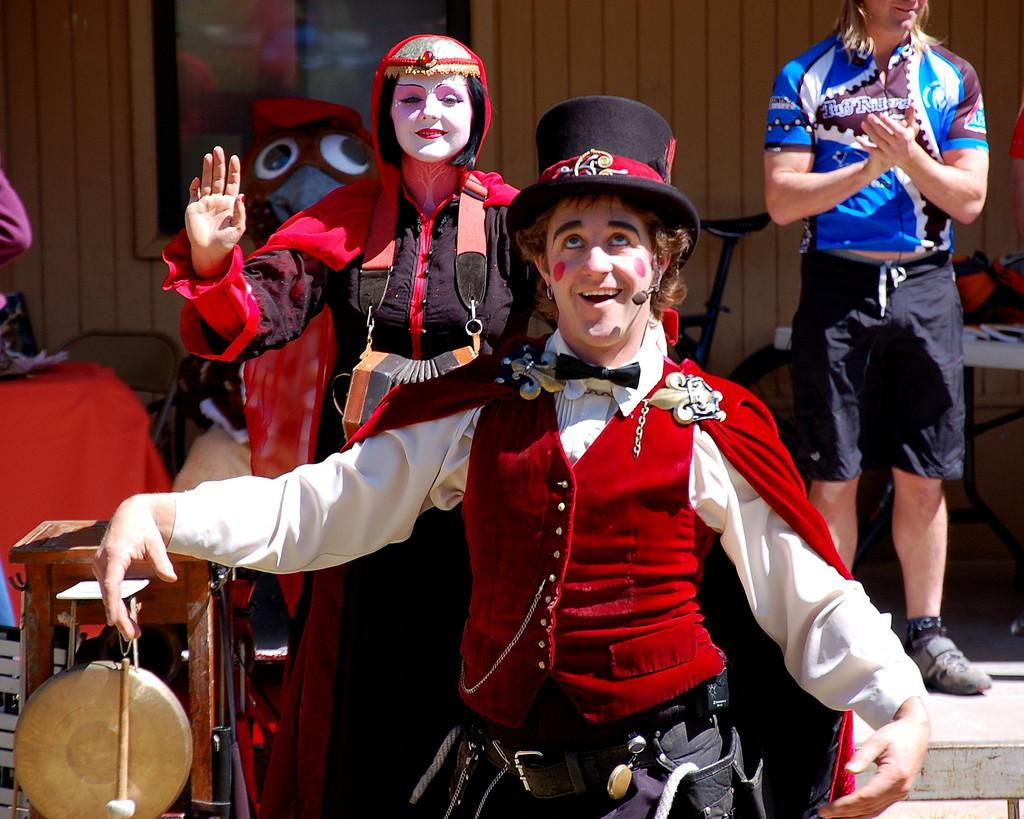What is happening in the center of the image? There are persons with costumes in the center of the image. What is the position of these persons in relation to the ground? These persons are standing on the ground. Can you describe the background of the image? There are persons visible in the background, along with a toy, a bicycle, a house, and a window. What type of ant can be seen interacting with the toy in the background? There is no ant present in the image, and therefore no such interaction can be observed. 